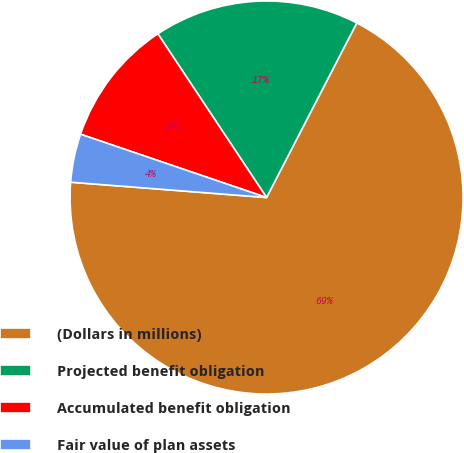<chart> <loc_0><loc_0><loc_500><loc_500><pie_chart><fcel>(Dollars in millions)<fcel>Projected benefit obligation<fcel>Accumulated benefit obligation<fcel>Fair value of plan assets<nl><fcel>68.65%<fcel>16.92%<fcel>10.45%<fcel>3.98%<nl></chart> 